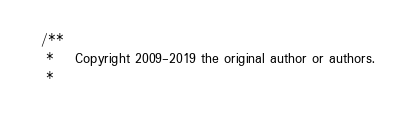<code> <loc_0><loc_0><loc_500><loc_500><_Java_>/**
 *    Copyright 2009-2019 the original author or authors.
 *</code> 